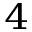<formula> <loc_0><loc_0><loc_500><loc_500>^ { 4 }</formula> 